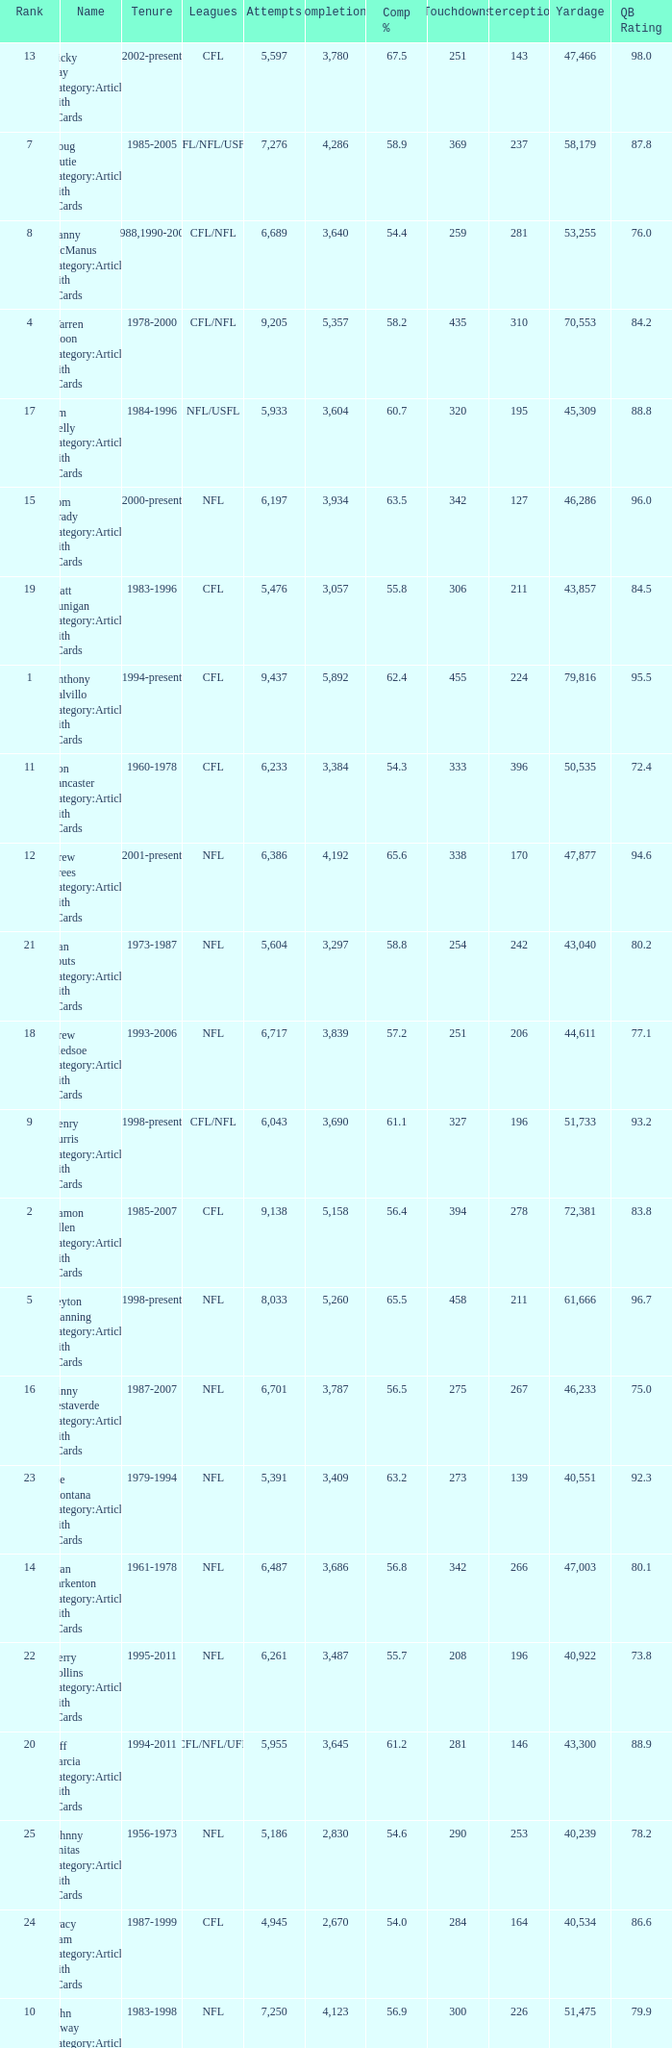What is the number of interceptions with less than 3,487 completions , more than 40,551 yardage, and the comp % is 55.8? 211.0. 